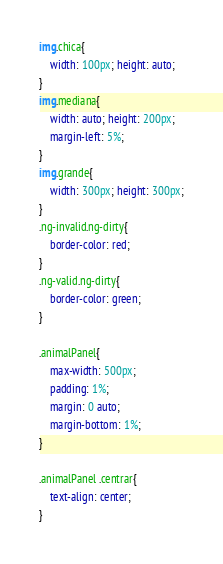<code> <loc_0><loc_0><loc_500><loc_500><_CSS_>img.chica{
	width: 100px; height: auto;
}
img.mediana{
	width: auto; height: 200px;
	margin-left: 5%;
}
img.grande{
	width: 300px; height: 300px;
}
.ng-invalid.ng-dirty{
	border-color: red;
}
.ng-valid.ng-dirty{
	border-color: green;
}

.animalPanel{
	max-width: 500px;
	padding: 1%;
	margin: 0 auto;
	margin-bottom: 1%;
}

.animalPanel .centrar{
	text-align: center;
}</code> 